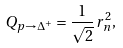Convert formula to latex. <formula><loc_0><loc_0><loc_500><loc_500>Q _ { p \to \Delta ^ { + } } = \frac { 1 } { \sqrt { 2 } } \, r ^ { 2 } _ { n } ,</formula> 